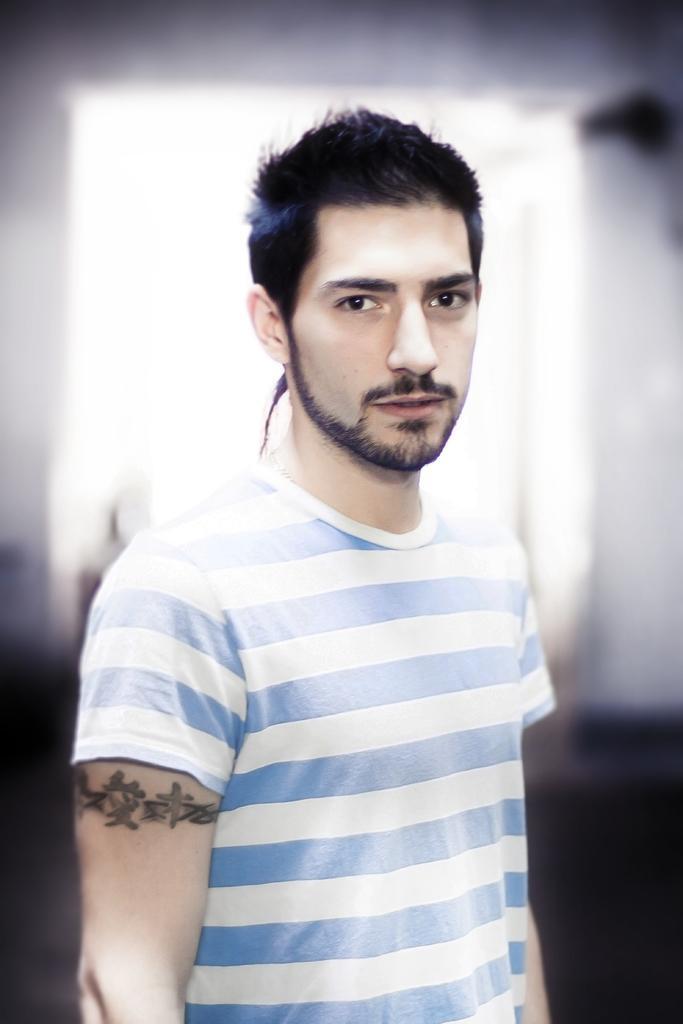Can you describe this image briefly? In this image there is a man standing wearing blue and white t-shirt, also there is a tattoo on his hand. 